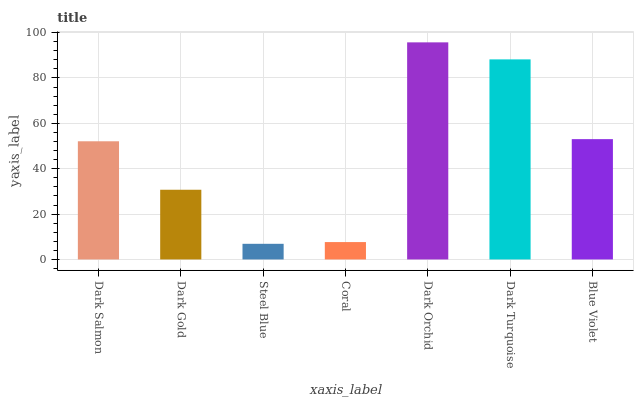Is Steel Blue the minimum?
Answer yes or no. Yes. Is Dark Orchid the maximum?
Answer yes or no. Yes. Is Dark Gold the minimum?
Answer yes or no. No. Is Dark Gold the maximum?
Answer yes or no. No. Is Dark Salmon greater than Dark Gold?
Answer yes or no. Yes. Is Dark Gold less than Dark Salmon?
Answer yes or no. Yes. Is Dark Gold greater than Dark Salmon?
Answer yes or no. No. Is Dark Salmon less than Dark Gold?
Answer yes or no. No. Is Dark Salmon the high median?
Answer yes or no. Yes. Is Dark Salmon the low median?
Answer yes or no. Yes. Is Dark Turquoise the high median?
Answer yes or no. No. Is Dark Orchid the low median?
Answer yes or no. No. 